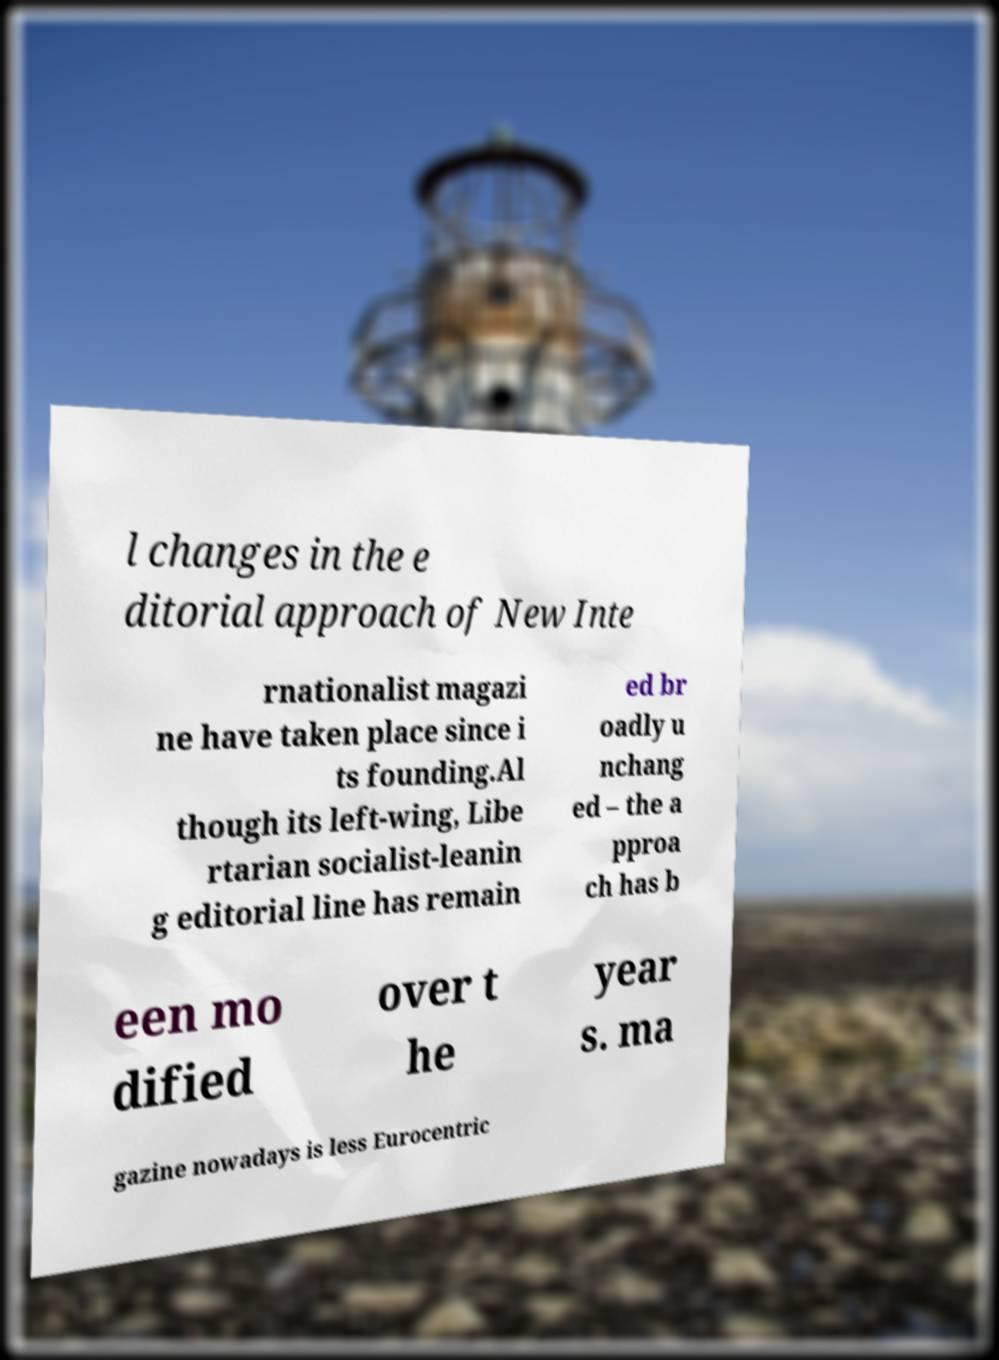Can you read and provide the text displayed in the image?This photo seems to have some interesting text. Can you extract and type it out for me? l changes in the e ditorial approach of New Inte rnationalist magazi ne have taken place since i ts founding.Al though its left-wing, Libe rtarian socialist-leanin g editorial line has remain ed br oadly u nchang ed – the a pproa ch has b een mo dified over t he year s. ma gazine nowadays is less Eurocentric 